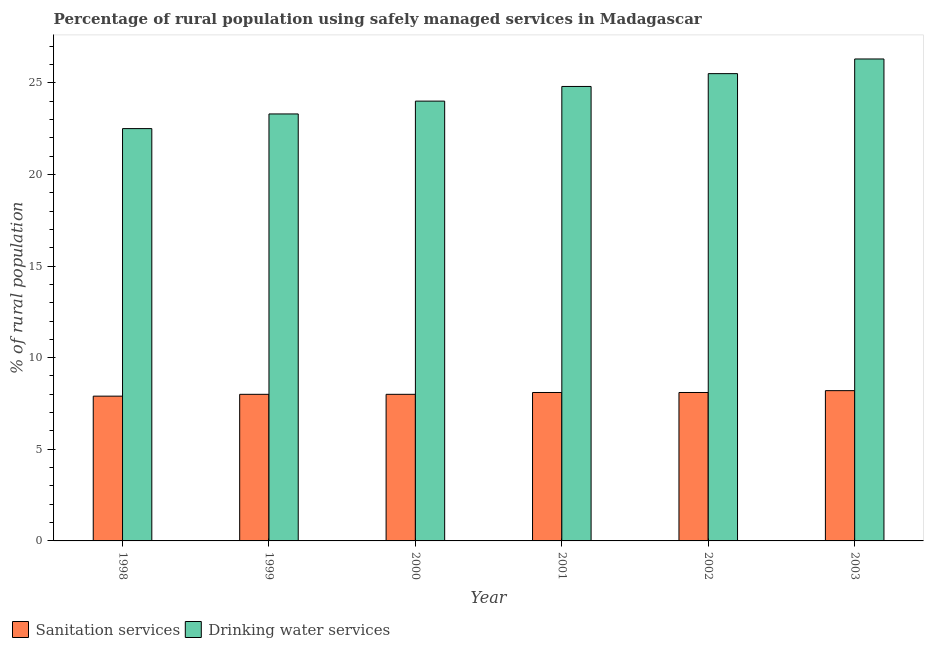How many different coloured bars are there?
Offer a terse response. 2. Are the number of bars per tick equal to the number of legend labels?
Provide a short and direct response. Yes. In how many cases, is the number of bars for a given year not equal to the number of legend labels?
Your answer should be compact. 0. What is the percentage of rural population who used drinking water services in 2001?
Keep it short and to the point. 24.8. Across all years, what is the minimum percentage of rural population who used drinking water services?
Make the answer very short. 22.5. In which year was the percentage of rural population who used sanitation services maximum?
Offer a terse response. 2003. What is the total percentage of rural population who used sanitation services in the graph?
Your answer should be compact. 48.3. What is the difference between the percentage of rural population who used sanitation services in 2002 and that in 2003?
Provide a short and direct response. -0.1. What is the difference between the percentage of rural population who used drinking water services in 2000 and the percentage of rural population who used sanitation services in 1999?
Your response must be concise. 0.7. What is the average percentage of rural population who used sanitation services per year?
Give a very brief answer. 8.05. In how many years, is the percentage of rural population who used sanitation services greater than 18 %?
Offer a very short reply. 0. What is the ratio of the percentage of rural population who used sanitation services in 2001 to that in 2002?
Give a very brief answer. 1. Is the percentage of rural population who used drinking water services in 2000 less than that in 2001?
Your answer should be compact. Yes. What is the difference between the highest and the second highest percentage of rural population who used sanitation services?
Your answer should be compact. 0.1. What is the difference between the highest and the lowest percentage of rural population who used sanitation services?
Your answer should be very brief. 0.3. In how many years, is the percentage of rural population who used sanitation services greater than the average percentage of rural population who used sanitation services taken over all years?
Offer a very short reply. 3. What does the 2nd bar from the left in 1998 represents?
Give a very brief answer. Drinking water services. What does the 1st bar from the right in 1999 represents?
Your answer should be very brief. Drinking water services. How many bars are there?
Offer a terse response. 12. How many years are there in the graph?
Keep it short and to the point. 6. What is the difference between two consecutive major ticks on the Y-axis?
Offer a very short reply. 5. Does the graph contain any zero values?
Offer a very short reply. No. What is the title of the graph?
Provide a succinct answer. Percentage of rural population using safely managed services in Madagascar. What is the label or title of the Y-axis?
Your response must be concise. % of rural population. What is the % of rural population of Drinking water services in 1998?
Keep it short and to the point. 22.5. What is the % of rural population of Drinking water services in 1999?
Make the answer very short. 23.3. What is the % of rural population of Drinking water services in 2000?
Keep it short and to the point. 24. What is the % of rural population of Drinking water services in 2001?
Offer a terse response. 24.8. What is the % of rural population in Sanitation services in 2002?
Ensure brevity in your answer.  8.1. What is the % of rural population in Drinking water services in 2002?
Your answer should be compact. 25.5. What is the % of rural population in Drinking water services in 2003?
Make the answer very short. 26.3. Across all years, what is the maximum % of rural population of Drinking water services?
Ensure brevity in your answer.  26.3. Across all years, what is the minimum % of rural population of Sanitation services?
Make the answer very short. 7.9. Across all years, what is the minimum % of rural population in Drinking water services?
Your answer should be very brief. 22.5. What is the total % of rural population of Sanitation services in the graph?
Offer a very short reply. 48.3. What is the total % of rural population of Drinking water services in the graph?
Your answer should be very brief. 146.4. What is the difference between the % of rural population in Sanitation services in 1998 and that in 2000?
Offer a very short reply. -0.1. What is the difference between the % of rural population in Sanitation services in 1998 and that in 2001?
Your response must be concise. -0.2. What is the difference between the % of rural population in Drinking water services in 1998 and that in 2001?
Keep it short and to the point. -2.3. What is the difference between the % of rural population of Drinking water services in 1998 and that in 2002?
Your answer should be very brief. -3. What is the difference between the % of rural population in Sanitation services in 1998 and that in 2003?
Make the answer very short. -0.3. What is the difference between the % of rural population in Drinking water services in 1998 and that in 2003?
Provide a succinct answer. -3.8. What is the difference between the % of rural population of Sanitation services in 1999 and that in 2003?
Give a very brief answer. -0.2. What is the difference between the % of rural population of Drinking water services in 1999 and that in 2003?
Provide a short and direct response. -3. What is the difference between the % of rural population in Drinking water services in 2000 and that in 2001?
Offer a terse response. -0.8. What is the difference between the % of rural population of Sanitation services in 2000 and that in 2002?
Give a very brief answer. -0.1. What is the difference between the % of rural population of Drinking water services in 2001 and that in 2002?
Give a very brief answer. -0.7. What is the difference between the % of rural population in Drinking water services in 2001 and that in 2003?
Your answer should be compact. -1.5. What is the difference between the % of rural population of Sanitation services in 2002 and that in 2003?
Offer a terse response. -0.1. What is the difference between the % of rural population of Sanitation services in 1998 and the % of rural population of Drinking water services in 1999?
Your answer should be compact. -15.4. What is the difference between the % of rural population in Sanitation services in 1998 and the % of rural population in Drinking water services in 2000?
Your answer should be compact. -16.1. What is the difference between the % of rural population of Sanitation services in 1998 and the % of rural population of Drinking water services in 2001?
Offer a very short reply. -16.9. What is the difference between the % of rural population in Sanitation services in 1998 and the % of rural population in Drinking water services in 2002?
Offer a very short reply. -17.6. What is the difference between the % of rural population of Sanitation services in 1998 and the % of rural population of Drinking water services in 2003?
Keep it short and to the point. -18.4. What is the difference between the % of rural population of Sanitation services in 1999 and the % of rural population of Drinking water services in 2001?
Keep it short and to the point. -16.8. What is the difference between the % of rural population in Sanitation services in 1999 and the % of rural population in Drinking water services in 2002?
Provide a succinct answer. -17.5. What is the difference between the % of rural population in Sanitation services in 1999 and the % of rural population in Drinking water services in 2003?
Give a very brief answer. -18.3. What is the difference between the % of rural population in Sanitation services in 2000 and the % of rural population in Drinking water services in 2001?
Provide a succinct answer. -16.8. What is the difference between the % of rural population in Sanitation services in 2000 and the % of rural population in Drinking water services in 2002?
Your answer should be very brief. -17.5. What is the difference between the % of rural population in Sanitation services in 2000 and the % of rural population in Drinking water services in 2003?
Make the answer very short. -18.3. What is the difference between the % of rural population in Sanitation services in 2001 and the % of rural population in Drinking water services in 2002?
Provide a succinct answer. -17.4. What is the difference between the % of rural population in Sanitation services in 2001 and the % of rural population in Drinking water services in 2003?
Offer a very short reply. -18.2. What is the difference between the % of rural population in Sanitation services in 2002 and the % of rural population in Drinking water services in 2003?
Your response must be concise. -18.2. What is the average % of rural population of Sanitation services per year?
Your answer should be very brief. 8.05. What is the average % of rural population in Drinking water services per year?
Offer a terse response. 24.4. In the year 1998, what is the difference between the % of rural population in Sanitation services and % of rural population in Drinking water services?
Give a very brief answer. -14.6. In the year 1999, what is the difference between the % of rural population of Sanitation services and % of rural population of Drinking water services?
Give a very brief answer. -15.3. In the year 2001, what is the difference between the % of rural population in Sanitation services and % of rural population in Drinking water services?
Keep it short and to the point. -16.7. In the year 2002, what is the difference between the % of rural population of Sanitation services and % of rural population of Drinking water services?
Provide a short and direct response. -17.4. In the year 2003, what is the difference between the % of rural population of Sanitation services and % of rural population of Drinking water services?
Provide a succinct answer. -18.1. What is the ratio of the % of rural population in Sanitation services in 1998 to that in 1999?
Offer a terse response. 0.99. What is the ratio of the % of rural population of Drinking water services in 1998 to that in 1999?
Your answer should be very brief. 0.97. What is the ratio of the % of rural population in Sanitation services in 1998 to that in 2000?
Provide a succinct answer. 0.99. What is the ratio of the % of rural population of Sanitation services in 1998 to that in 2001?
Offer a terse response. 0.98. What is the ratio of the % of rural population in Drinking water services in 1998 to that in 2001?
Offer a very short reply. 0.91. What is the ratio of the % of rural population in Sanitation services in 1998 to that in 2002?
Offer a terse response. 0.98. What is the ratio of the % of rural population in Drinking water services in 1998 to that in 2002?
Offer a terse response. 0.88. What is the ratio of the % of rural population in Sanitation services in 1998 to that in 2003?
Give a very brief answer. 0.96. What is the ratio of the % of rural population in Drinking water services in 1998 to that in 2003?
Make the answer very short. 0.86. What is the ratio of the % of rural population of Drinking water services in 1999 to that in 2000?
Give a very brief answer. 0.97. What is the ratio of the % of rural population in Sanitation services in 1999 to that in 2001?
Your response must be concise. 0.99. What is the ratio of the % of rural population in Drinking water services in 1999 to that in 2001?
Your answer should be compact. 0.94. What is the ratio of the % of rural population in Drinking water services in 1999 to that in 2002?
Offer a very short reply. 0.91. What is the ratio of the % of rural population of Sanitation services in 1999 to that in 2003?
Offer a terse response. 0.98. What is the ratio of the % of rural population of Drinking water services in 1999 to that in 2003?
Provide a short and direct response. 0.89. What is the ratio of the % of rural population of Drinking water services in 2000 to that in 2001?
Give a very brief answer. 0.97. What is the ratio of the % of rural population in Sanitation services in 2000 to that in 2002?
Provide a short and direct response. 0.99. What is the ratio of the % of rural population in Drinking water services in 2000 to that in 2002?
Ensure brevity in your answer.  0.94. What is the ratio of the % of rural population in Sanitation services in 2000 to that in 2003?
Your response must be concise. 0.98. What is the ratio of the % of rural population of Drinking water services in 2000 to that in 2003?
Offer a very short reply. 0.91. What is the ratio of the % of rural population in Sanitation services in 2001 to that in 2002?
Provide a succinct answer. 1. What is the ratio of the % of rural population in Drinking water services in 2001 to that in 2002?
Your answer should be very brief. 0.97. What is the ratio of the % of rural population in Sanitation services in 2001 to that in 2003?
Your answer should be very brief. 0.99. What is the ratio of the % of rural population of Drinking water services in 2001 to that in 2003?
Offer a terse response. 0.94. What is the ratio of the % of rural population in Sanitation services in 2002 to that in 2003?
Your response must be concise. 0.99. What is the ratio of the % of rural population in Drinking water services in 2002 to that in 2003?
Provide a short and direct response. 0.97. What is the difference between the highest and the lowest % of rural population in Drinking water services?
Offer a terse response. 3.8. 